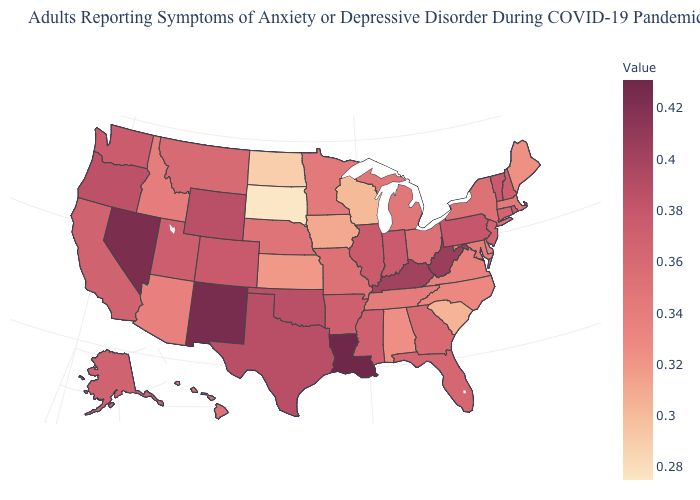Which states have the highest value in the USA?
Be succinct. Louisiana. Which states have the lowest value in the USA?
Quick response, please. South Dakota. Does New Mexico have the highest value in the West?
Concise answer only. Yes. Among the states that border North Dakota , does Minnesota have the lowest value?
Answer briefly. No. Is the legend a continuous bar?
Be succinct. Yes. 